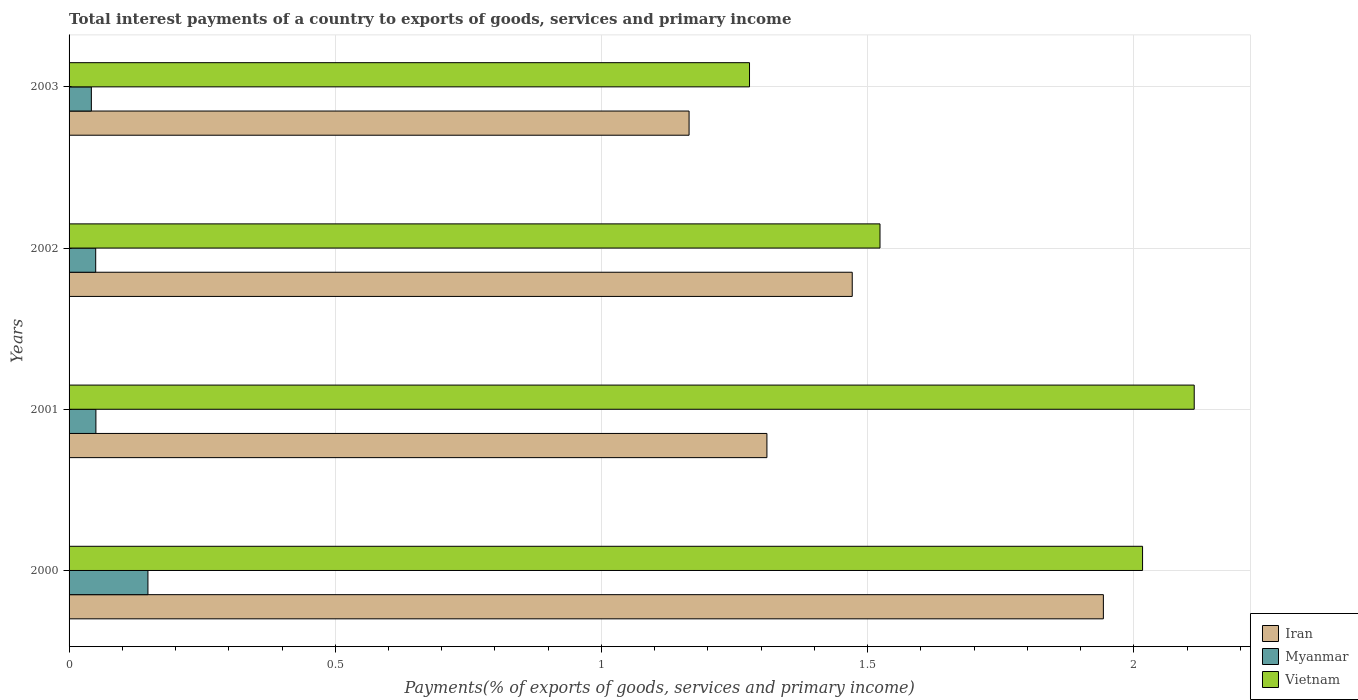Are the number of bars per tick equal to the number of legend labels?
Ensure brevity in your answer.  Yes. How many bars are there on the 2nd tick from the top?
Give a very brief answer. 3. How many bars are there on the 3rd tick from the bottom?
Your answer should be very brief. 3. What is the label of the 1st group of bars from the top?
Provide a succinct answer. 2003. What is the total interest payments in Iran in 2002?
Keep it short and to the point. 1.47. Across all years, what is the maximum total interest payments in Vietnam?
Make the answer very short. 2.11. Across all years, what is the minimum total interest payments in Myanmar?
Keep it short and to the point. 0.04. What is the total total interest payments in Vietnam in the graph?
Your answer should be compact. 6.93. What is the difference between the total interest payments in Iran in 2002 and that in 2003?
Keep it short and to the point. 0.31. What is the difference between the total interest payments in Iran in 2000 and the total interest payments in Myanmar in 2003?
Keep it short and to the point. 1.9. What is the average total interest payments in Iran per year?
Your answer should be compact. 1.47. In the year 2003, what is the difference between the total interest payments in Vietnam and total interest payments in Iran?
Provide a short and direct response. 0.11. In how many years, is the total interest payments in Myanmar greater than 1.2 %?
Provide a succinct answer. 0. What is the ratio of the total interest payments in Iran in 2000 to that in 2003?
Make the answer very short. 1.67. Is the total interest payments in Iran in 2000 less than that in 2001?
Offer a terse response. No. What is the difference between the highest and the second highest total interest payments in Vietnam?
Give a very brief answer. 0.1. What is the difference between the highest and the lowest total interest payments in Iran?
Give a very brief answer. 0.78. In how many years, is the total interest payments in Iran greater than the average total interest payments in Iran taken over all years?
Ensure brevity in your answer.  1. What does the 3rd bar from the top in 2001 represents?
Your response must be concise. Iran. What does the 1st bar from the bottom in 2003 represents?
Your answer should be very brief. Iran. How many bars are there?
Provide a short and direct response. 12. What is the difference between two consecutive major ticks on the X-axis?
Offer a very short reply. 0.5. Are the values on the major ticks of X-axis written in scientific E-notation?
Offer a terse response. No. Does the graph contain grids?
Provide a short and direct response. Yes. Where does the legend appear in the graph?
Offer a very short reply. Bottom right. What is the title of the graph?
Provide a succinct answer. Total interest payments of a country to exports of goods, services and primary income. What is the label or title of the X-axis?
Your answer should be very brief. Payments(% of exports of goods, services and primary income). What is the label or title of the Y-axis?
Keep it short and to the point. Years. What is the Payments(% of exports of goods, services and primary income) in Iran in 2000?
Your answer should be very brief. 1.94. What is the Payments(% of exports of goods, services and primary income) in Myanmar in 2000?
Your response must be concise. 0.15. What is the Payments(% of exports of goods, services and primary income) of Vietnam in 2000?
Provide a succinct answer. 2.02. What is the Payments(% of exports of goods, services and primary income) of Iran in 2001?
Provide a succinct answer. 1.31. What is the Payments(% of exports of goods, services and primary income) in Myanmar in 2001?
Offer a very short reply. 0.05. What is the Payments(% of exports of goods, services and primary income) in Vietnam in 2001?
Your answer should be compact. 2.11. What is the Payments(% of exports of goods, services and primary income) of Iran in 2002?
Give a very brief answer. 1.47. What is the Payments(% of exports of goods, services and primary income) of Myanmar in 2002?
Your answer should be compact. 0.05. What is the Payments(% of exports of goods, services and primary income) in Vietnam in 2002?
Provide a succinct answer. 1.52. What is the Payments(% of exports of goods, services and primary income) of Iran in 2003?
Your response must be concise. 1.16. What is the Payments(% of exports of goods, services and primary income) in Myanmar in 2003?
Give a very brief answer. 0.04. What is the Payments(% of exports of goods, services and primary income) of Vietnam in 2003?
Ensure brevity in your answer.  1.28. Across all years, what is the maximum Payments(% of exports of goods, services and primary income) in Iran?
Your answer should be very brief. 1.94. Across all years, what is the maximum Payments(% of exports of goods, services and primary income) of Myanmar?
Keep it short and to the point. 0.15. Across all years, what is the maximum Payments(% of exports of goods, services and primary income) in Vietnam?
Make the answer very short. 2.11. Across all years, what is the minimum Payments(% of exports of goods, services and primary income) in Iran?
Provide a succinct answer. 1.16. Across all years, what is the minimum Payments(% of exports of goods, services and primary income) of Myanmar?
Offer a very short reply. 0.04. Across all years, what is the minimum Payments(% of exports of goods, services and primary income) of Vietnam?
Ensure brevity in your answer.  1.28. What is the total Payments(% of exports of goods, services and primary income) in Iran in the graph?
Give a very brief answer. 5.89. What is the total Payments(% of exports of goods, services and primary income) of Myanmar in the graph?
Offer a very short reply. 0.29. What is the total Payments(% of exports of goods, services and primary income) in Vietnam in the graph?
Your answer should be very brief. 6.93. What is the difference between the Payments(% of exports of goods, services and primary income) of Iran in 2000 and that in 2001?
Give a very brief answer. 0.63. What is the difference between the Payments(% of exports of goods, services and primary income) of Myanmar in 2000 and that in 2001?
Your response must be concise. 0.1. What is the difference between the Payments(% of exports of goods, services and primary income) of Vietnam in 2000 and that in 2001?
Provide a succinct answer. -0.1. What is the difference between the Payments(% of exports of goods, services and primary income) in Iran in 2000 and that in 2002?
Your answer should be compact. 0.47. What is the difference between the Payments(% of exports of goods, services and primary income) in Myanmar in 2000 and that in 2002?
Offer a very short reply. 0.1. What is the difference between the Payments(% of exports of goods, services and primary income) of Vietnam in 2000 and that in 2002?
Keep it short and to the point. 0.49. What is the difference between the Payments(% of exports of goods, services and primary income) of Iran in 2000 and that in 2003?
Give a very brief answer. 0.78. What is the difference between the Payments(% of exports of goods, services and primary income) of Myanmar in 2000 and that in 2003?
Make the answer very short. 0.11. What is the difference between the Payments(% of exports of goods, services and primary income) in Vietnam in 2000 and that in 2003?
Make the answer very short. 0.74. What is the difference between the Payments(% of exports of goods, services and primary income) of Iran in 2001 and that in 2002?
Keep it short and to the point. -0.16. What is the difference between the Payments(% of exports of goods, services and primary income) in Myanmar in 2001 and that in 2002?
Keep it short and to the point. 0. What is the difference between the Payments(% of exports of goods, services and primary income) of Vietnam in 2001 and that in 2002?
Provide a succinct answer. 0.59. What is the difference between the Payments(% of exports of goods, services and primary income) in Iran in 2001 and that in 2003?
Provide a short and direct response. 0.15. What is the difference between the Payments(% of exports of goods, services and primary income) of Myanmar in 2001 and that in 2003?
Offer a terse response. 0.01. What is the difference between the Payments(% of exports of goods, services and primary income) of Vietnam in 2001 and that in 2003?
Provide a short and direct response. 0.84. What is the difference between the Payments(% of exports of goods, services and primary income) of Iran in 2002 and that in 2003?
Provide a succinct answer. 0.31. What is the difference between the Payments(% of exports of goods, services and primary income) of Myanmar in 2002 and that in 2003?
Ensure brevity in your answer.  0.01. What is the difference between the Payments(% of exports of goods, services and primary income) of Vietnam in 2002 and that in 2003?
Provide a succinct answer. 0.25. What is the difference between the Payments(% of exports of goods, services and primary income) in Iran in 2000 and the Payments(% of exports of goods, services and primary income) in Myanmar in 2001?
Keep it short and to the point. 1.89. What is the difference between the Payments(% of exports of goods, services and primary income) of Iran in 2000 and the Payments(% of exports of goods, services and primary income) of Vietnam in 2001?
Give a very brief answer. -0.17. What is the difference between the Payments(% of exports of goods, services and primary income) in Myanmar in 2000 and the Payments(% of exports of goods, services and primary income) in Vietnam in 2001?
Your response must be concise. -1.97. What is the difference between the Payments(% of exports of goods, services and primary income) in Iran in 2000 and the Payments(% of exports of goods, services and primary income) in Myanmar in 2002?
Offer a terse response. 1.89. What is the difference between the Payments(% of exports of goods, services and primary income) of Iran in 2000 and the Payments(% of exports of goods, services and primary income) of Vietnam in 2002?
Ensure brevity in your answer.  0.42. What is the difference between the Payments(% of exports of goods, services and primary income) of Myanmar in 2000 and the Payments(% of exports of goods, services and primary income) of Vietnam in 2002?
Your answer should be very brief. -1.38. What is the difference between the Payments(% of exports of goods, services and primary income) of Iran in 2000 and the Payments(% of exports of goods, services and primary income) of Myanmar in 2003?
Your answer should be very brief. 1.9. What is the difference between the Payments(% of exports of goods, services and primary income) of Iran in 2000 and the Payments(% of exports of goods, services and primary income) of Vietnam in 2003?
Make the answer very short. 0.66. What is the difference between the Payments(% of exports of goods, services and primary income) in Myanmar in 2000 and the Payments(% of exports of goods, services and primary income) in Vietnam in 2003?
Provide a succinct answer. -1.13. What is the difference between the Payments(% of exports of goods, services and primary income) of Iran in 2001 and the Payments(% of exports of goods, services and primary income) of Myanmar in 2002?
Offer a terse response. 1.26. What is the difference between the Payments(% of exports of goods, services and primary income) of Iran in 2001 and the Payments(% of exports of goods, services and primary income) of Vietnam in 2002?
Offer a terse response. -0.21. What is the difference between the Payments(% of exports of goods, services and primary income) in Myanmar in 2001 and the Payments(% of exports of goods, services and primary income) in Vietnam in 2002?
Provide a succinct answer. -1.47. What is the difference between the Payments(% of exports of goods, services and primary income) in Iran in 2001 and the Payments(% of exports of goods, services and primary income) in Myanmar in 2003?
Make the answer very short. 1.27. What is the difference between the Payments(% of exports of goods, services and primary income) of Iran in 2001 and the Payments(% of exports of goods, services and primary income) of Vietnam in 2003?
Your answer should be very brief. 0.03. What is the difference between the Payments(% of exports of goods, services and primary income) of Myanmar in 2001 and the Payments(% of exports of goods, services and primary income) of Vietnam in 2003?
Offer a terse response. -1.23. What is the difference between the Payments(% of exports of goods, services and primary income) of Iran in 2002 and the Payments(% of exports of goods, services and primary income) of Myanmar in 2003?
Offer a very short reply. 1.43. What is the difference between the Payments(% of exports of goods, services and primary income) of Iran in 2002 and the Payments(% of exports of goods, services and primary income) of Vietnam in 2003?
Ensure brevity in your answer.  0.19. What is the difference between the Payments(% of exports of goods, services and primary income) of Myanmar in 2002 and the Payments(% of exports of goods, services and primary income) of Vietnam in 2003?
Your answer should be compact. -1.23. What is the average Payments(% of exports of goods, services and primary income) of Iran per year?
Your response must be concise. 1.47. What is the average Payments(% of exports of goods, services and primary income) in Myanmar per year?
Keep it short and to the point. 0.07. What is the average Payments(% of exports of goods, services and primary income) in Vietnam per year?
Your response must be concise. 1.73. In the year 2000, what is the difference between the Payments(% of exports of goods, services and primary income) in Iran and Payments(% of exports of goods, services and primary income) in Myanmar?
Give a very brief answer. 1.79. In the year 2000, what is the difference between the Payments(% of exports of goods, services and primary income) of Iran and Payments(% of exports of goods, services and primary income) of Vietnam?
Your response must be concise. -0.07. In the year 2000, what is the difference between the Payments(% of exports of goods, services and primary income) of Myanmar and Payments(% of exports of goods, services and primary income) of Vietnam?
Your answer should be very brief. -1.87. In the year 2001, what is the difference between the Payments(% of exports of goods, services and primary income) in Iran and Payments(% of exports of goods, services and primary income) in Myanmar?
Make the answer very short. 1.26. In the year 2001, what is the difference between the Payments(% of exports of goods, services and primary income) in Iran and Payments(% of exports of goods, services and primary income) in Vietnam?
Offer a terse response. -0.8. In the year 2001, what is the difference between the Payments(% of exports of goods, services and primary income) of Myanmar and Payments(% of exports of goods, services and primary income) of Vietnam?
Make the answer very short. -2.06. In the year 2002, what is the difference between the Payments(% of exports of goods, services and primary income) of Iran and Payments(% of exports of goods, services and primary income) of Myanmar?
Offer a terse response. 1.42. In the year 2002, what is the difference between the Payments(% of exports of goods, services and primary income) of Iran and Payments(% of exports of goods, services and primary income) of Vietnam?
Your response must be concise. -0.05. In the year 2002, what is the difference between the Payments(% of exports of goods, services and primary income) in Myanmar and Payments(% of exports of goods, services and primary income) in Vietnam?
Offer a terse response. -1.47. In the year 2003, what is the difference between the Payments(% of exports of goods, services and primary income) in Iran and Payments(% of exports of goods, services and primary income) in Myanmar?
Provide a succinct answer. 1.12. In the year 2003, what is the difference between the Payments(% of exports of goods, services and primary income) of Iran and Payments(% of exports of goods, services and primary income) of Vietnam?
Ensure brevity in your answer.  -0.11. In the year 2003, what is the difference between the Payments(% of exports of goods, services and primary income) of Myanmar and Payments(% of exports of goods, services and primary income) of Vietnam?
Your answer should be very brief. -1.24. What is the ratio of the Payments(% of exports of goods, services and primary income) in Iran in 2000 to that in 2001?
Give a very brief answer. 1.48. What is the ratio of the Payments(% of exports of goods, services and primary income) of Myanmar in 2000 to that in 2001?
Provide a short and direct response. 2.94. What is the ratio of the Payments(% of exports of goods, services and primary income) of Vietnam in 2000 to that in 2001?
Offer a terse response. 0.95. What is the ratio of the Payments(% of exports of goods, services and primary income) in Iran in 2000 to that in 2002?
Provide a short and direct response. 1.32. What is the ratio of the Payments(% of exports of goods, services and primary income) of Myanmar in 2000 to that in 2002?
Offer a terse response. 2.96. What is the ratio of the Payments(% of exports of goods, services and primary income) of Vietnam in 2000 to that in 2002?
Your answer should be compact. 1.32. What is the ratio of the Payments(% of exports of goods, services and primary income) in Iran in 2000 to that in 2003?
Your answer should be compact. 1.67. What is the ratio of the Payments(% of exports of goods, services and primary income) in Myanmar in 2000 to that in 2003?
Your answer should be compact. 3.54. What is the ratio of the Payments(% of exports of goods, services and primary income) in Vietnam in 2000 to that in 2003?
Your answer should be very brief. 1.58. What is the ratio of the Payments(% of exports of goods, services and primary income) of Iran in 2001 to that in 2002?
Offer a very short reply. 0.89. What is the ratio of the Payments(% of exports of goods, services and primary income) of Myanmar in 2001 to that in 2002?
Offer a very short reply. 1.01. What is the ratio of the Payments(% of exports of goods, services and primary income) in Vietnam in 2001 to that in 2002?
Provide a succinct answer. 1.39. What is the ratio of the Payments(% of exports of goods, services and primary income) of Iran in 2001 to that in 2003?
Keep it short and to the point. 1.13. What is the ratio of the Payments(% of exports of goods, services and primary income) in Myanmar in 2001 to that in 2003?
Provide a short and direct response. 1.2. What is the ratio of the Payments(% of exports of goods, services and primary income) of Vietnam in 2001 to that in 2003?
Ensure brevity in your answer.  1.65. What is the ratio of the Payments(% of exports of goods, services and primary income) of Iran in 2002 to that in 2003?
Your response must be concise. 1.26. What is the ratio of the Payments(% of exports of goods, services and primary income) of Myanmar in 2002 to that in 2003?
Provide a short and direct response. 1.2. What is the ratio of the Payments(% of exports of goods, services and primary income) in Vietnam in 2002 to that in 2003?
Offer a terse response. 1.19. What is the difference between the highest and the second highest Payments(% of exports of goods, services and primary income) in Iran?
Ensure brevity in your answer.  0.47. What is the difference between the highest and the second highest Payments(% of exports of goods, services and primary income) of Myanmar?
Your answer should be very brief. 0.1. What is the difference between the highest and the second highest Payments(% of exports of goods, services and primary income) in Vietnam?
Give a very brief answer. 0.1. What is the difference between the highest and the lowest Payments(% of exports of goods, services and primary income) of Iran?
Offer a terse response. 0.78. What is the difference between the highest and the lowest Payments(% of exports of goods, services and primary income) of Myanmar?
Make the answer very short. 0.11. What is the difference between the highest and the lowest Payments(% of exports of goods, services and primary income) in Vietnam?
Provide a short and direct response. 0.84. 